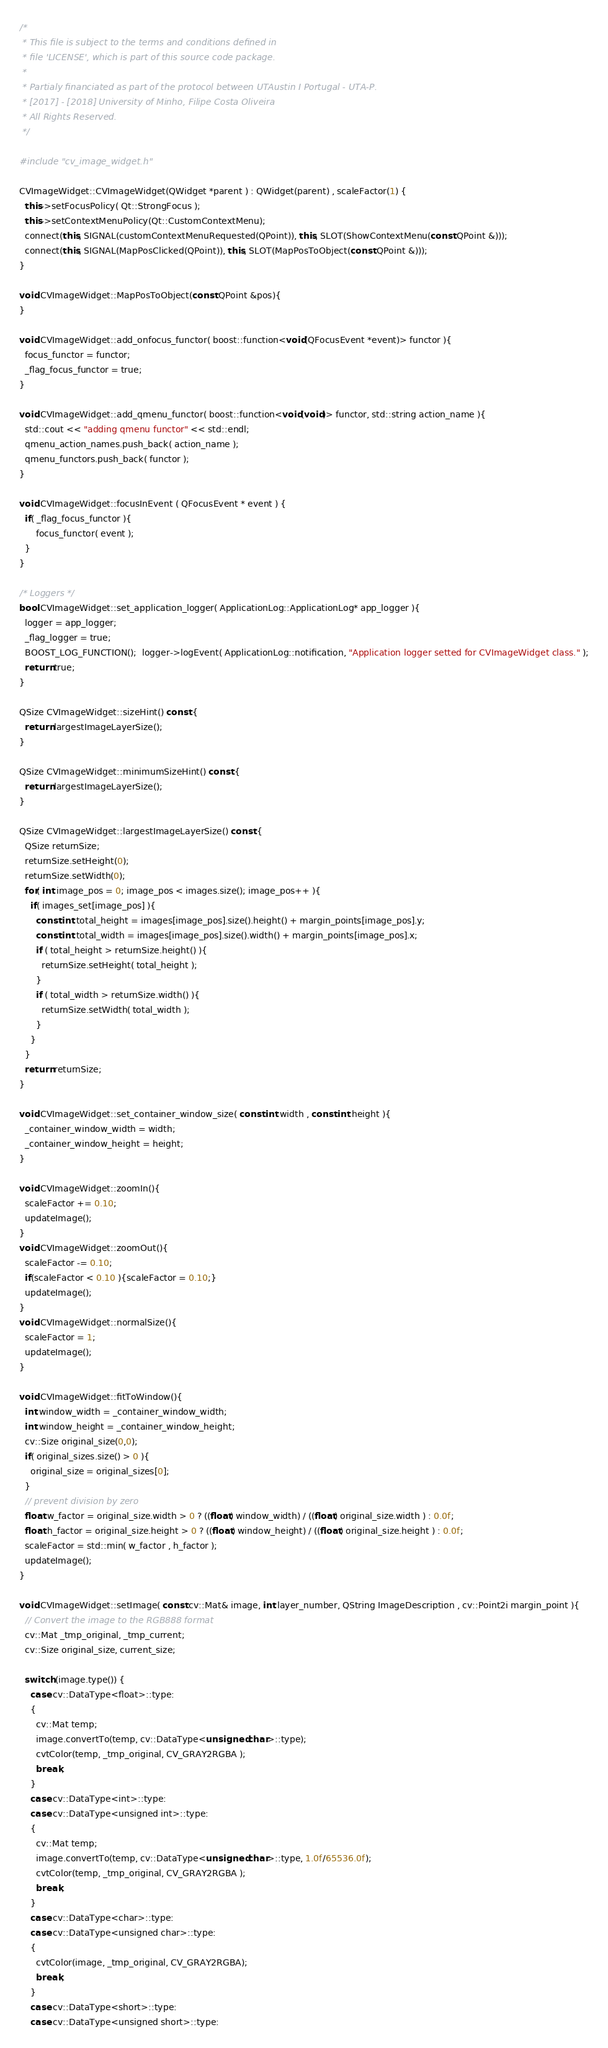Convert code to text. <code><loc_0><loc_0><loc_500><loc_500><_C++_>/*
 * This file is subject to the terms and conditions defined in
 * file 'LICENSE', which is part of this source code package.
 *
 * Partialy financiated as part of the protocol between UTAustin I Portugal - UTA-P.
 * [2017] - [2018] University of Minho, Filipe Costa Oliveira 
 * All Rights Reserved.
 */

#include "cv_image_widget.h"

CVImageWidget::CVImageWidget(QWidget *parent ) : QWidget(parent) , scaleFactor(1) {
  this->setFocusPolicy( Qt::StrongFocus );
  this->setContextMenuPolicy(Qt::CustomContextMenu);
  connect(this, SIGNAL(customContextMenuRequested(QPoint)), this, SLOT(ShowContextMenu(const QPoint &)));
  connect(this, SIGNAL(MapPosClicked(QPoint)), this, SLOT(MapPosToObject(const QPoint &)));
}

void CVImageWidget::MapPosToObject(const QPoint &pos){
}

void CVImageWidget::add_onfocus_functor( boost::function<void(QFocusEvent *event)> functor ){
  focus_functor = functor;
  _flag_focus_functor = true;
}

void CVImageWidget::add_qmenu_functor( boost::function<void(void)> functor, std::string action_name ){
  std::cout << "adding qmenu functor" << std::endl;
  qmenu_action_names.push_back( action_name );
  qmenu_functors.push_back( functor );
}

void CVImageWidget::focusInEvent ( QFocusEvent * event ) {
  if( _flag_focus_functor ){
      focus_functor( event );  
  }
}

/* Loggers */
bool CVImageWidget::set_application_logger( ApplicationLog::ApplicationLog* app_logger ){
  logger = app_logger;
  _flag_logger = true;
  BOOST_LOG_FUNCTION();  logger->logEvent( ApplicationLog::notification, "Application logger setted for CVImageWidget class." );
  return true;
}

QSize CVImageWidget::sizeHint() const {
  return largestImageLayerSize();
}

QSize CVImageWidget::minimumSizeHint() const {
  return largestImageLayerSize();
}

QSize CVImageWidget::largestImageLayerSize() const {
  QSize returnSize;
  returnSize.setHeight(0);
  returnSize.setWidth(0);
  for( int image_pos = 0; image_pos < images.size(); image_pos++ ){
    if( images_set[image_pos] ){
      const int total_height = images[image_pos].size().height() + margin_points[image_pos].y;
      const int total_width = images[image_pos].size().width() + margin_points[image_pos].x;
      if ( total_height > returnSize.height() ){
        returnSize.setHeight( total_height );
      }
      if ( total_width > returnSize.width() ){
        returnSize.setWidth( total_width );
      }
    }
  }
  return returnSize;
}

void CVImageWidget::set_container_window_size( const int width , const int height ){
  _container_window_width = width;
  _container_window_height = height;
}

void CVImageWidget::zoomIn(){
  scaleFactor += 0.10;
  updateImage();
}
void CVImageWidget::zoomOut(){
  scaleFactor -= 0.10;
  if(scaleFactor < 0.10 ){scaleFactor = 0.10;}
  updateImage();
}
void CVImageWidget::normalSize(){
  scaleFactor = 1;
  updateImage();
}

void CVImageWidget::fitToWindow(){
  int window_width = _container_window_width;
  int window_height = _container_window_height;
  cv::Size original_size(0,0);
  if( original_sizes.size() > 0 ){
    original_size = original_sizes[0];
  } 
  // prevent division by zero
  float w_factor = original_size.width > 0 ? ((float) window_width) / ((float) original_size.width ) : 0.0f;
  float h_factor = original_size.height > 0 ? ((float) window_height) / ((float) original_size.height ) : 0.0f;
  scaleFactor = std::min( w_factor , h_factor );
  updateImage();
}

void CVImageWidget::setImage( const cv::Mat& image, int layer_number, QString ImageDescription , cv::Point2i margin_point ){
  // Convert the image to the RGB888 format
  cv::Mat _tmp_original, _tmp_current;
  cv::Size original_size, current_size;

  switch (image.type()) {
    case cv::DataType<float>::type:
    {
      cv::Mat temp;
      image.convertTo(temp, cv::DataType<unsigned char>::type);
      cvtColor(temp, _tmp_original, CV_GRAY2RGBA );
      break;
    }
    case cv::DataType<int>::type:
    case cv::DataType<unsigned int>::type:
    {
      cv::Mat temp;
      image.convertTo(temp, cv::DataType<unsigned char>::type, 1.0f/65536.0f);
      cvtColor(temp, _tmp_original, CV_GRAY2RGBA );
      break;
    }
    case cv::DataType<char>::type:
    case cv::DataType<unsigned char>::type:
    {
      cvtColor(image, _tmp_original, CV_GRAY2RGBA);
      break;
    }
    case cv::DataType<short>::type:
    case cv::DataType<unsigned short>::type:</code> 